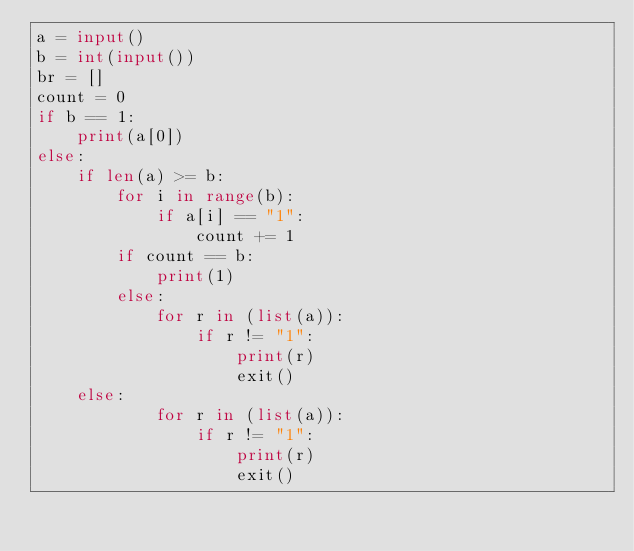<code> <loc_0><loc_0><loc_500><loc_500><_Python_>a = input()
b = int(input())
br = []
count = 0
if b == 1:
    print(a[0])
else:
    if len(a) >= b:
        for i in range(b):
            if a[i] == "1":
                count += 1
        if count == b:
            print(1)
        else:
            for r in (list(a)):
                if r != "1":
                    print(r)
                    exit()
    else:
            for r in (list(a)):
                if r != "1":
                    print(r)
                    exit()</code> 